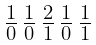Convert formula to latex. <formula><loc_0><loc_0><loc_500><loc_500>\begin{smallmatrix} 1 & 1 & 2 & 1 & 1 \\ \overline { 0 } & \overline { 0 } & \overline { 1 } & \overline { 0 } & \overline { 1 } \end{smallmatrix}</formula> 